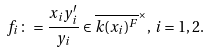Convert formula to latex. <formula><loc_0><loc_0><loc_500><loc_500>f _ { i } \colon = \frac { x _ { i } y ^ { \prime } _ { i } } { y _ { i } } \in \overline { k ( x _ { i } ) ^ { F } } ^ { \times } , \, i = 1 , 2 .</formula> 